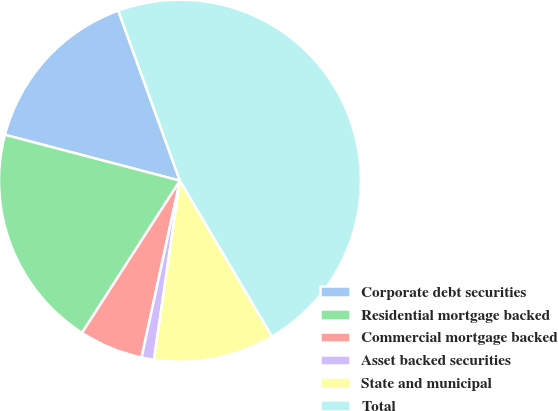Convert chart. <chart><loc_0><loc_0><loc_500><loc_500><pie_chart><fcel>Corporate debt securities<fcel>Residential mortgage backed<fcel>Commercial mortgage backed<fcel>Asset backed securities<fcel>State and municipal<fcel>Total<nl><fcel>15.38%<fcel>19.98%<fcel>5.7%<fcel>1.11%<fcel>10.79%<fcel>47.04%<nl></chart> 